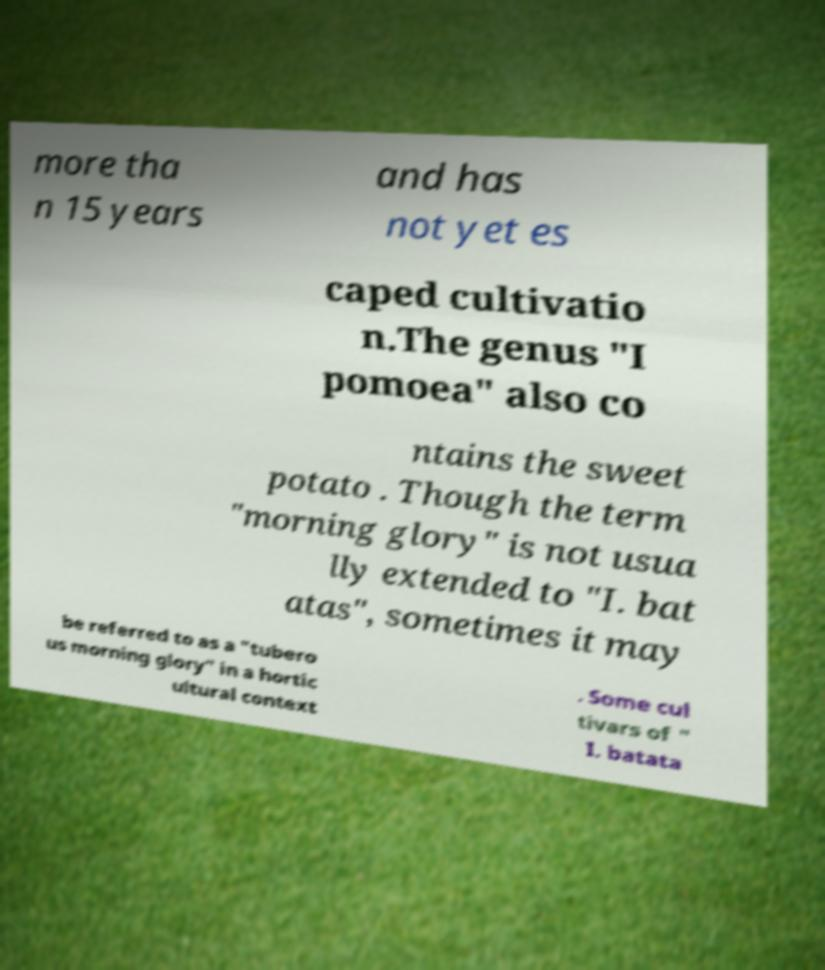Could you extract and type out the text from this image? more tha n 15 years and has not yet es caped cultivatio n.The genus "I pomoea" also co ntains the sweet potato . Though the term "morning glory" is not usua lly extended to "I. bat atas", sometimes it may be referred to as a "tubero us morning glory" in a hortic ultural context . Some cul tivars of " I. batata 